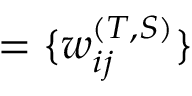<formula> <loc_0><loc_0><loc_500><loc_500>= \{ w _ { i j } ^ { ( T , S ) } \}</formula> 